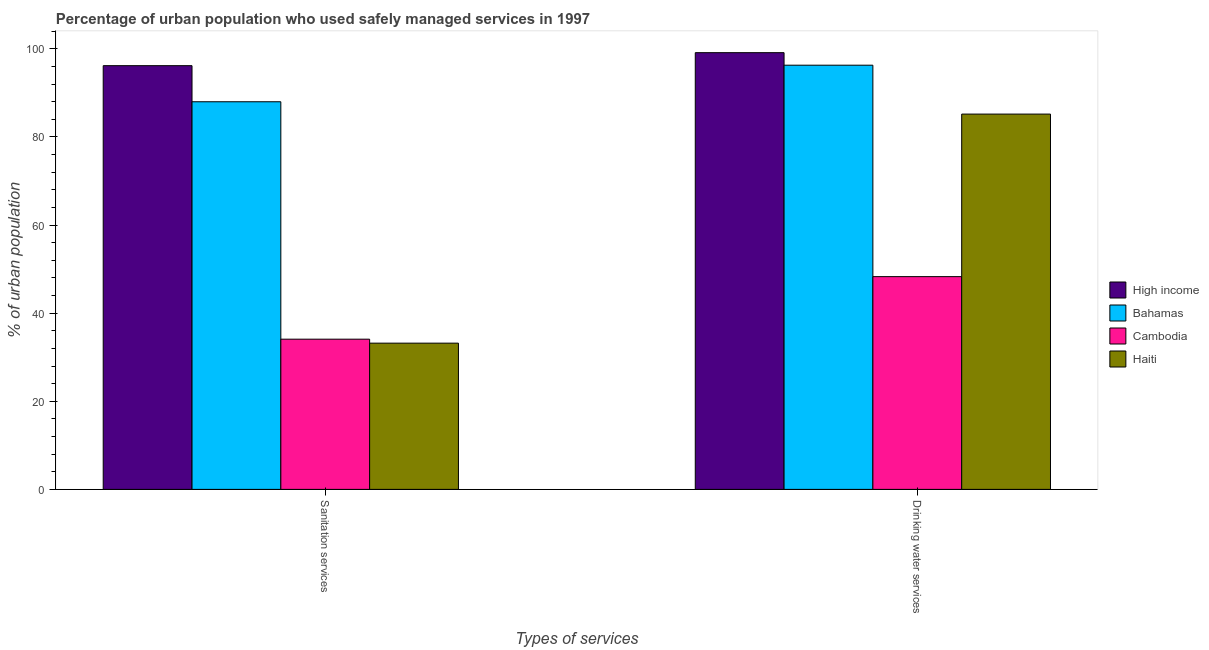How many groups of bars are there?
Provide a short and direct response. 2. Are the number of bars per tick equal to the number of legend labels?
Make the answer very short. Yes. Are the number of bars on each tick of the X-axis equal?
Offer a terse response. Yes. How many bars are there on the 2nd tick from the left?
Ensure brevity in your answer.  4. What is the label of the 1st group of bars from the left?
Provide a short and direct response. Sanitation services. What is the percentage of urban population who used sanitation services in Cambodia?
Ensure brevity in your answer.  34.1. Across all countries, what is the maximum percentage of urban population who used sanitation services?
Make the answer very short. 96.19. Across all countries, what is the minimum percentage of urban population who used sanitation services?
Offer a terse response. 33.2. In which country was the percentage of urban population who used sanitation services minimum?
Your answer should be compact. Haiti. What is the total percentage of urban population who used sanitation services in the graph?
Offer a terse response. 251.49. What is the difference between the percentage of urban population who used sanitation services in Bahamas and that in Cambodia?
Your response must be concise. 53.9. What is the difference between the percentage of urban population who used drinking water services in Cambodia and the percentage of urban population who used sanitation services in High income?
Give a very brief answer. -47.89. What is the average percentage of urban population who used sanitation services per country?
Offer a terse response. 62.87. What is the difference between the percentage of urban population who used sanitation services and percentage of urban population who used drinking water services in High income?
Your answer should be compact. -2.95. In how many countries, is the percentage of urban population who used sanitation services greater than 72 %?
Make the answer very short. 2. What is the ratio of the percentage of urban population who used sanitation services in Bahamas to that in High income?
Keep it short and to the point. 0.91. What does the 2nd bar from the left in Drinking water services represents?
Provide a succinct answer. Bahamas. What does the 3rd bar from the right in Drinking water services represents?
Keep it short and to the point. Bahamas. Where does the legend appear in the graph?
Offer a very short reply. Center right. How many legend labels are there?
Your response must be concise. 4. How are the legend labels stacked?
Provide a succinct answer. Vertical. What is the title of the graph?
Offer a very short reply. Percentage of urban population who used safely managed services in 1997. What is the label or title of the X-axis?
Give a very brief answer. Types of services. What is the label or title of the Y-axis?
Your response must be concise. % of urban population. What is the % of urban population in High income in Sanitation services?
Give a very brief answer. 96.19. What is the % of urban population of Bahamas in Sanitation services?
Give a very brief answer. 88. What is the % of urban population in Cambodia in Sanitation services?
Give a very brief answer. 34.1. What is the % of urban population of Haiti in Sanitation services?
Make the answer very short. 33.2. What is the % of urban population of High income in Drinking water services?
Provide a short and direct response. 99.15. What is the % of urban population of Bahamas in Drinking water services?
Provide a succinct answer. 96.3. What is the % of urban population of Cambodia in Drinking water services?
Ensure brevity in your answer.  48.3. What is the % of urban population of Haiti in Drinking water services?
Offer a very short reply. 85.2. Across all Types of services, what is the maximum % of urban population in High income?
Make the answer very short. 99.15. Across all Types of services, what is the maximum % of urban population in Bahamas?
Your answer should be very brief. 96.3. Across all Types of services, what is the maximum % of urban population of Cambodia?
Offer a terse response. 48.3. Across all Types of services, what is the maximum % of urban population of Haiti?
Keep it short and to the point. 85.2. Across all Types of services, what is the minimum % of urban population in High income?
Provide a succinct answer. 96.19. Across all Types of services, what is the minimum % of urban population of Cambodia?
Your answer should be very brief. 34.1. Across all Types of services, what is the minimum % of urban population in Haiti?
Offer a very short reply. 33.2. What is the total % of urban population of High income in the graph?
Provide a short and direct response. 195.34. What is the total % of urban population of Bahamas in the graph?
Make the answer very short. 184.3. What is the total % of urban population of Cambodia in the graph?
Your answer should be compact. 82.4. What is the total % of urban population of Haiti in the graph?
Offer a terse response. 118.4. What is the difference between the % of urban population in High income in Sanitation services and that in Drinking water services?
Your answer should be very brief. -2.95. What is the difference between the % of urban population in Bahamas in Sanitation services and that in Drinking water services?
Your answer should be compact. -8.3. What is the difference between the % of urban population in Cambodia in Sanitation services and that in Drinking water services?
Your answer should be very brief. -14.2. What is the difference between the % of urban population of Haiti in Sanitation services and that in Drinking water services?
Ensure brevity in your answer.  -52. What is the difference between the % of urban population of High income in Sanitation services and the % of urban population of Bahamas in Drinking water services?
Make the answer very short. -0.11. What is the difference between the % of urban population of High income in Sanitation services and the % of urban population of Cambodia in Drinking water services?
Ensure brevity in your answer.  47.89. What is the difference between the % of urban population of High income in Sanitation services and the % of urban population of Haiti in Drinking water services?
Your answer should be compact. 10.99. What is the difference between the % of urban population of Bahamas in Sanitation services and the % of urban population of Cambodia in Drinking water services?
Ensure brevity in your answer.  39.7. What is the difference between the % of urban population of Bahamas in Sanitation services and the % of urban population of Haiti in Drinking water services?
Ensure brevity in your answer.  2.8. What is the difference between the % of urban population in Cambodia in Sanitation services and the % of urban population in Haiti in Drinking water services?
Provide a short and direct response. -51.1. What is the average % of urban population of High income per Types of services?
Make the answer very short. 97.67. What is the average % of urban population of Bahamas per Types of services?
Offer a very short reply. 92.15. What is the average % of urban population of Cambodia per Types of services?
Your answer should be very brief. 41.2. What is the average % of urban population of Haiti per Types of services?
Your answer should be compact. 59.2. What is the difference between the % of urban population of High income and % of urban population of Bahamas in Sanitation services?
Ensure brevity in your answer.  8.19. What is the difference between the % of urban population of High income and % of urban population of Cambodia in Sanitation services?
Your response must be concise. 62.09. What is the difference between the % of urban population in High income and % of urban population in Haiti in Sanitation services?
Keep it short and to the point. 62.99. What is the difference between the % of urban population of Bahamas and % of urban population of Cambodia in Sanitation services?
Your response must be concise. 53.9. What is the difference between the % of urban population of Bahamas and % of urban population of Haiti in Sanitation services?
Offer a very short reply. 54.8. What is the difference between the % of urban population of Cambodia and % of urban population of Haiti in Sanitation services?
Your answer should be compact. 0.9. What is the difference between the % of urban population in High income and % of urban population in Bahamas in Drinking water services?
Make the answer very short. 2.85. What is the difference between the % of urban population of High income and % of urban population of Cambodia in Drinking water services?
Offer a very short reply. 50.85. What is the difference between the % of urban population of High income and % of urban population of Haiti in Drinking water services?
Your answer should be very brief. 13.95. What is the difference between the % of urban population in Cambodia and % of urban population in Haiti in Drinking water services?
Keep it short and to the point. -36.9. What is the ratio of the % of urban population of High income in Sanitation services to that in Drinking water services?
Provide a succinct answer. 0.97. What is the ratio of the % of urban population in Bahamas in Sanitation services to that in Drinking water services?
Make the answer very short. 0.91. What is the ratio of the % of urban population of Cambodia in Sanitation services to that in Drinking water services?
Your response must be concise. 0.71. What is the ratio of the % of urban population in Haiti in Sanitation services to that in Drinking water services?
Offer a very short reply. 0.39. What is the difference between the highest and the second highest % of urban population of High income?
Your answer should be very brief. 2.95. What is the difference between the highest and the second highest % of urban population in Bahamas?
Give a very brief answer. 8.3. What is the difference between the highest and the second highest % of urban population of Cambodia?
Ensure brevity in your answer.  14.2. What is the difference between the highest and the second highest % of urban population of Haiti?
Provide a succinct answer. 52. What is the difference between the highest and the lowest % of urban population of High income?
Make the answer very short. 2.95. What is the difference between the highest and the lowest % of urban population of Bahamas?
Provide a short and direct response. 8.3. 